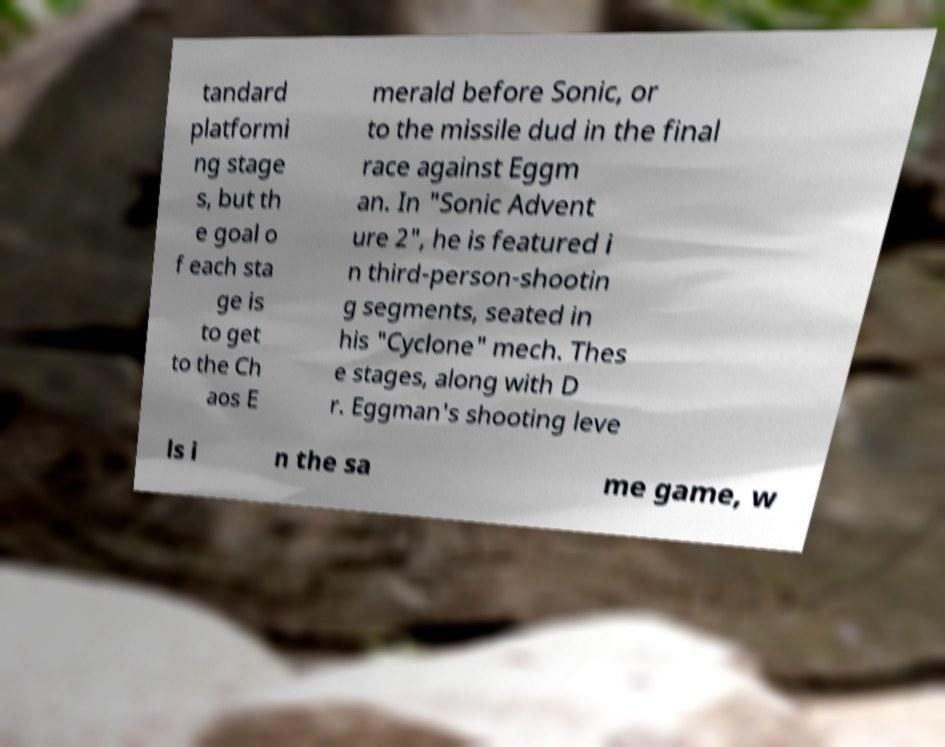Can you accurately transcribe the text from the provided image for me? tandard platformi ng stage s, but th e goal o f each sta ge is to get to the Ch aos E merald before Sonic, or to the missile dud in the final race against Eggm an. In "Sonic Advent ure 2", he is featured i n third-person-shootin g segments, seated in his "Cyclone" mech. Thes e stages, along with D r. Eggman's shooting leve ls i n the sa me game, w 